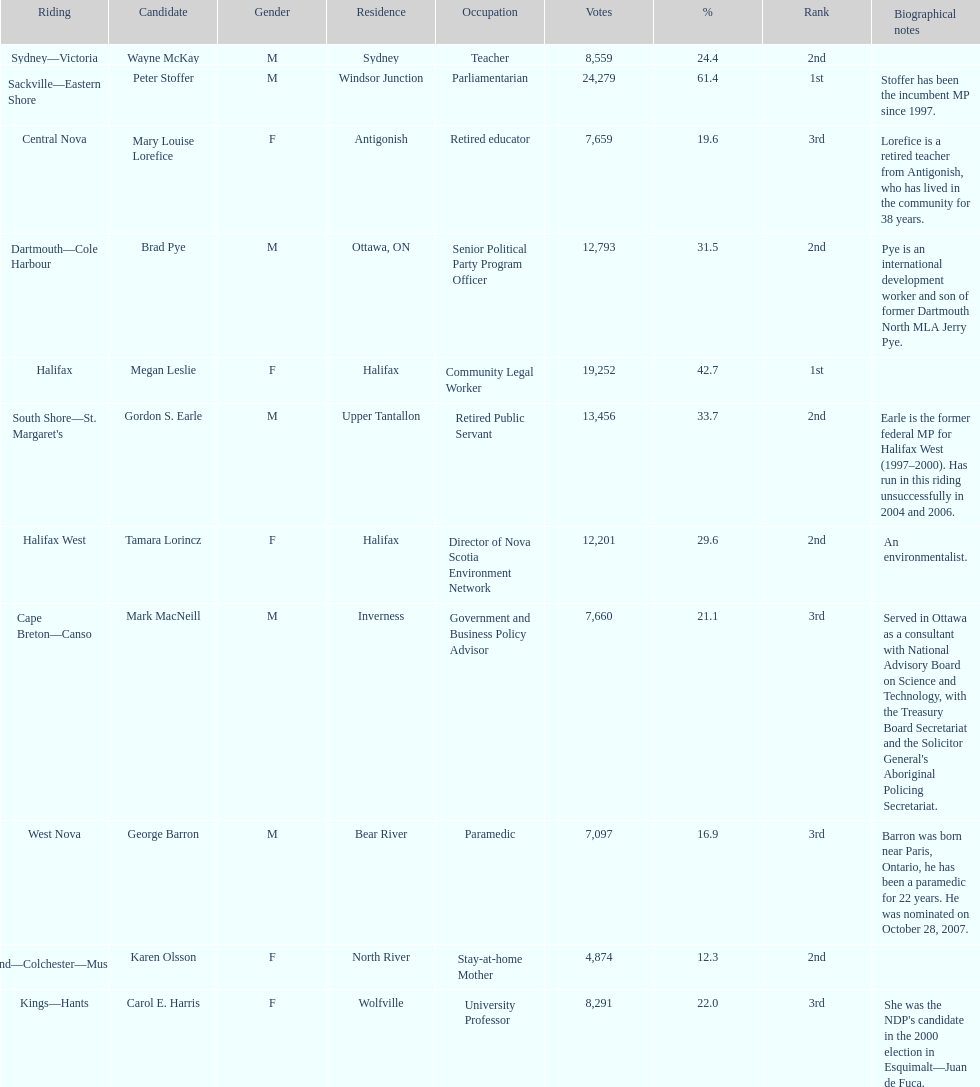What is the total number of candidates? 11. 